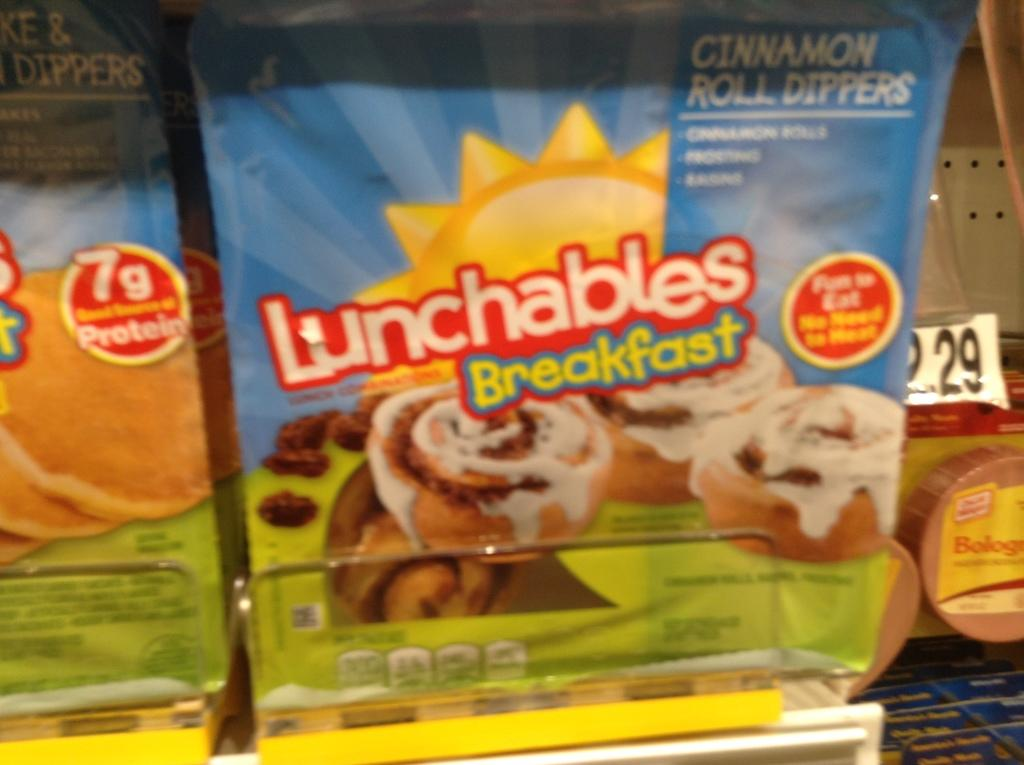What is the main subject of the image? The main subject of the image is a group of food packages. Where are the food packages located in the image? The food packages are placed on a rack. What else can be seen in the background of the image? There are numbers on a paper in the background of the image. Can you tell me how many geese are depicted on the paper with numbers in the background? There are no geese depicted on the paper with numbers in the background; it only contains numbers. What type of battle is taking place in the image? There is no battle present in the image; it features a group of food packages on a rack and numbers on a paper in the background. 